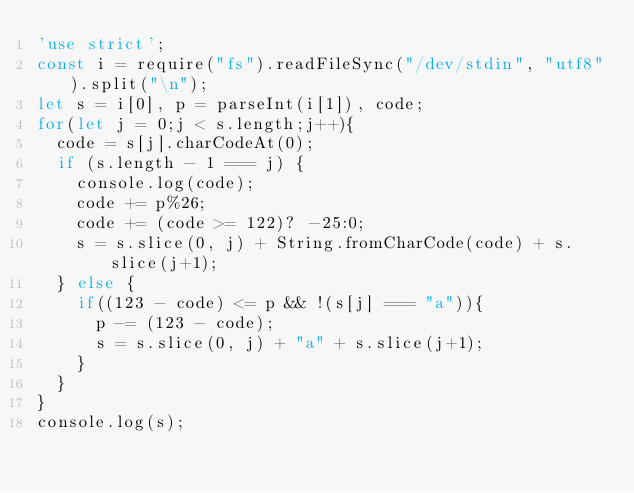Convert code to text. <code><loc_0><loc_0><loc_500><loc_500><_JavaScript_>'use strict';
const i = require("fs").readFileSync("/dev/stdin", "utf8").split("\n");
let s = i[0], p = parseInt(i[1]), code;
for(let j = 0;j < s.length;j++){
  code = s[j].charCodeAt(0);
  if (s.length - 1 === j) {
    console.log(code);
    code += p%26;
    code += (code >= 122)? -25:0;
    s = s.slice(0, j) + String.fromCharCode(code) + s.slice(j+1);
  } else {
    if((123 - code) <= p && !(s[j] === "a")){
      p -= (123 - code);
      s = s.slice(0, j) + "a" + s.slice(j+1);
    }
  }
}
console.log(s);</code> 